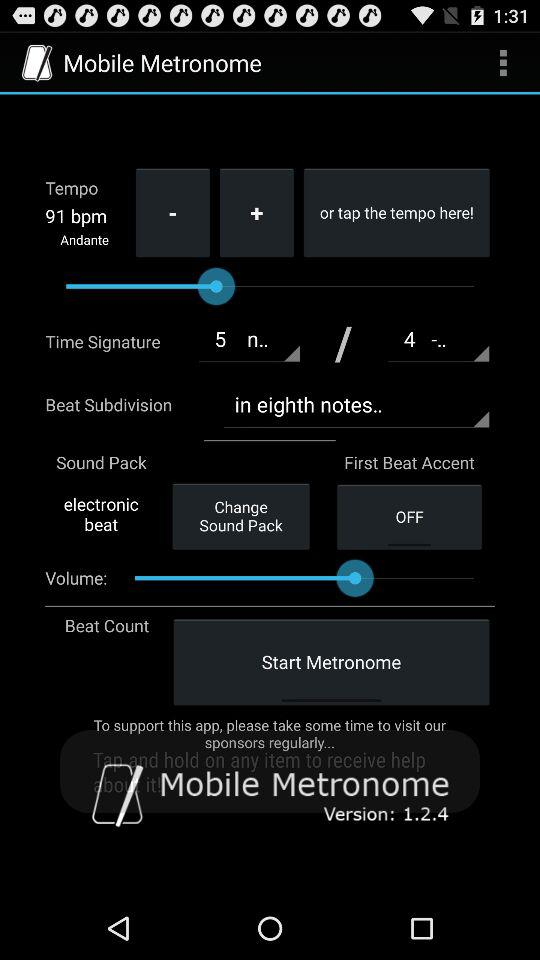What is the time signature?
When the provided information is insufficient, respond with <no answer>. <no answer> 